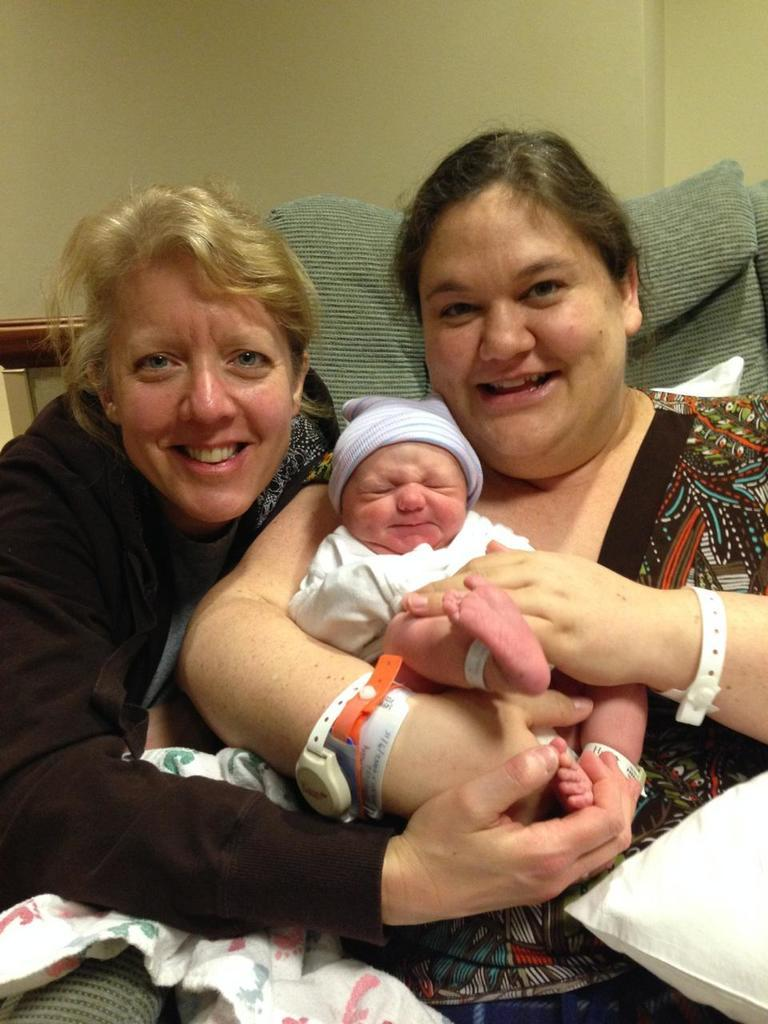How many people are in the image? There are two people in the image. What are the people doing in the image? The people are smiling and holding a baby. Can you describe the object that appears to be soft and fluffy? There is a pillow visible in the image. What is visible in the background of the image? There is a wall in the background of the image. What type of rifle is the person holding in the image? There is no rifle present in the image; the people are holding a baby. What emotion might the people be feeling based on their expressions? The people are smiling, which suggests they might be feeling happiness or joy. 